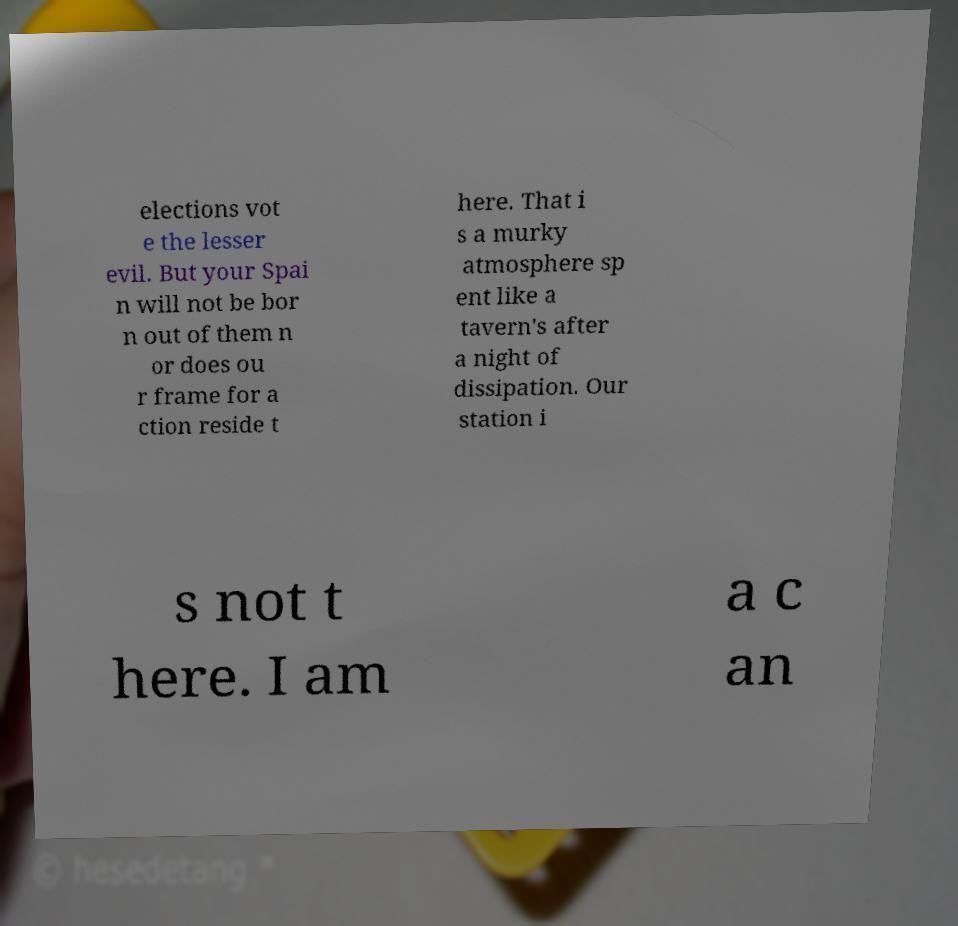Please identify and transcribe the text found in this image. elections vot e the lesser evil. But your Spai n will not be bor n out of them n or does ou r frame for a ction reside t here. That i s a murky atmosphere sp ent like a tavern's after a night of dissipation. Our station i s not t here. I am a c an 